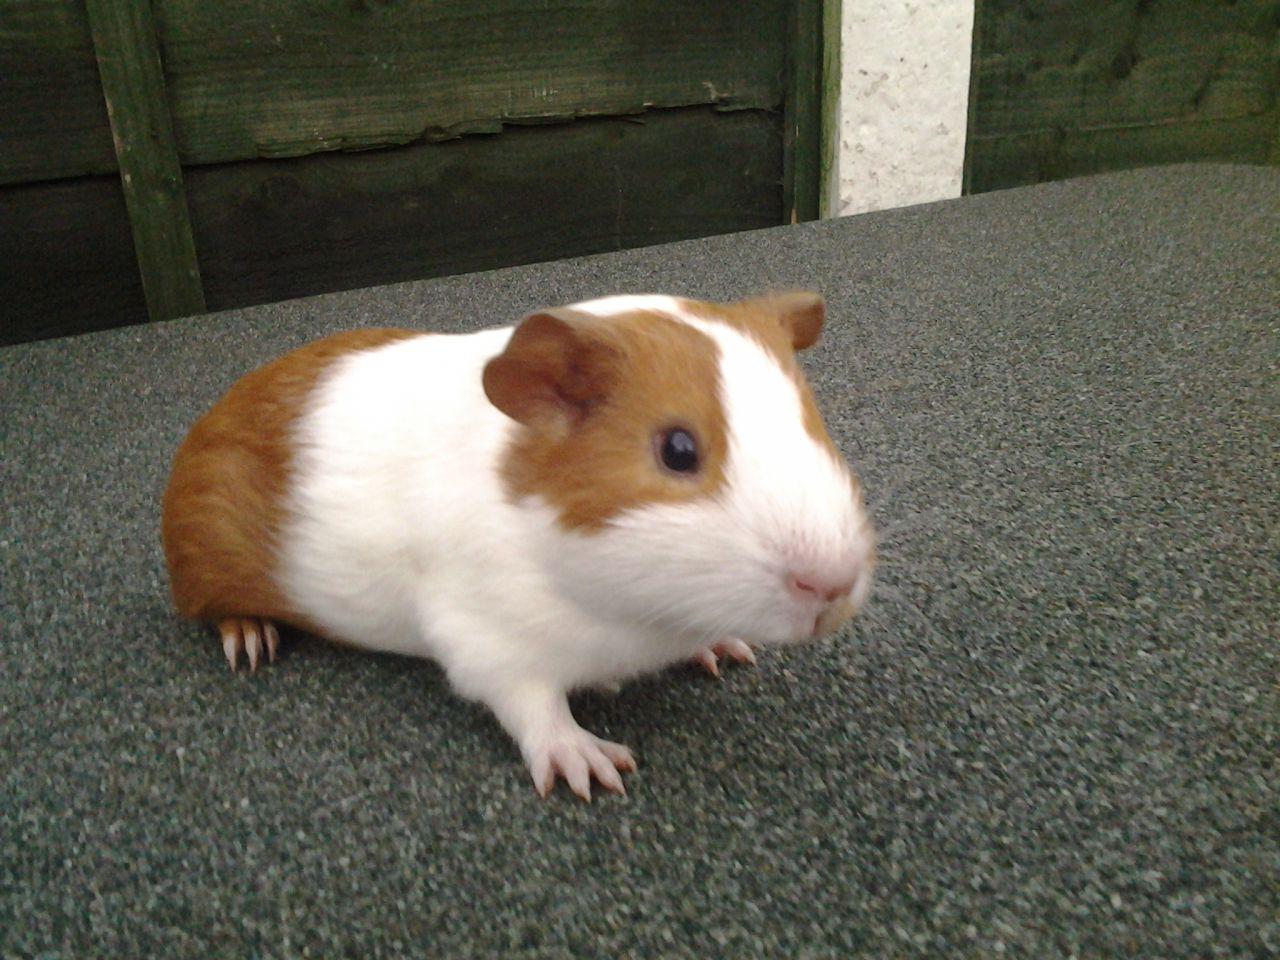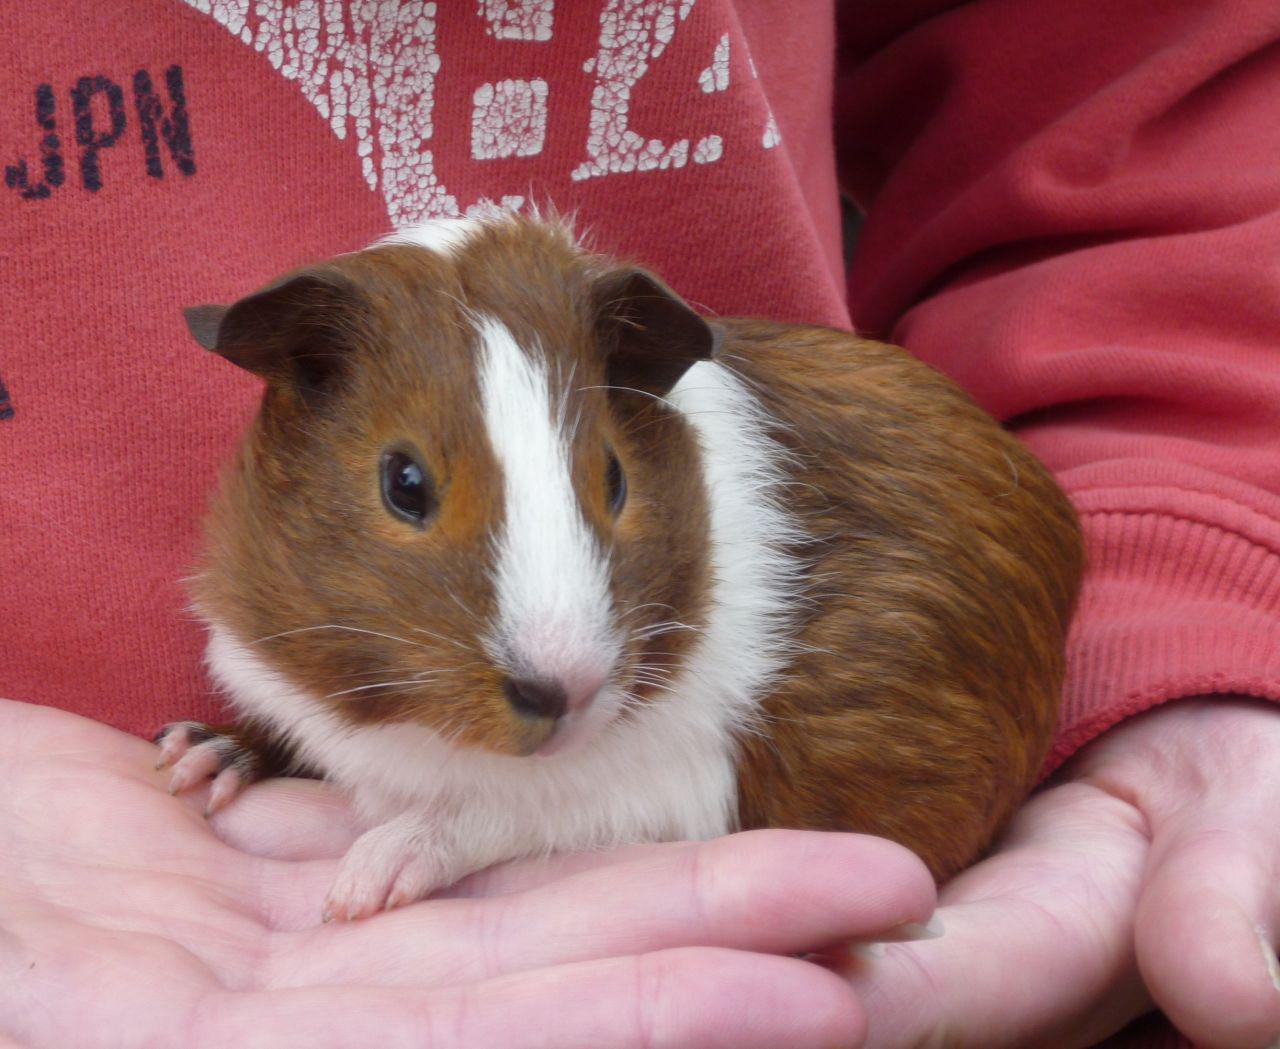The first image is the image on the left, the second image is the image on the right. Considering the images on both sides, is "An image shows a pair of hamsters nibbling on something green." valid? Answer yes or no. No. The first image is the image on the left, the second image is the image on the right. Given the left and right images, does the statement "There is at least one guinea pig eating a green food item" hold true? Answer yes or no. No. 